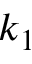Convert formula to latex. <formula><loc_0><loc_0><loc_500><loc_500>k _ { 1 }</formula> 